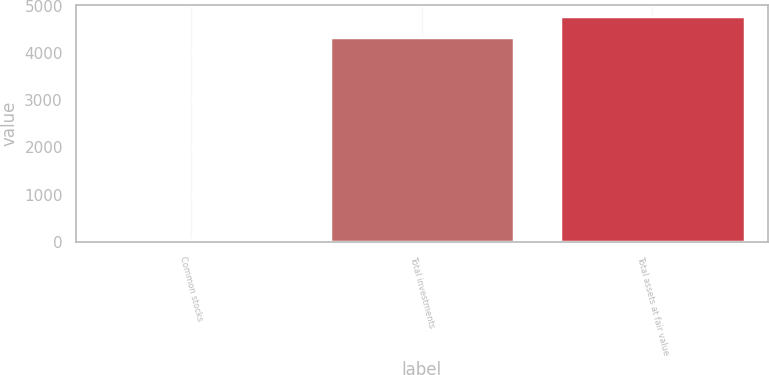<chart> <loc_0><loc_0><loc_500><loc_500><bar_chart><fcel>Common stocks<fcel>Total investments<fcel>Total assets at fair value<nl><fcel>25<fcel>4355<fcel>4792.1<nl></chart> 